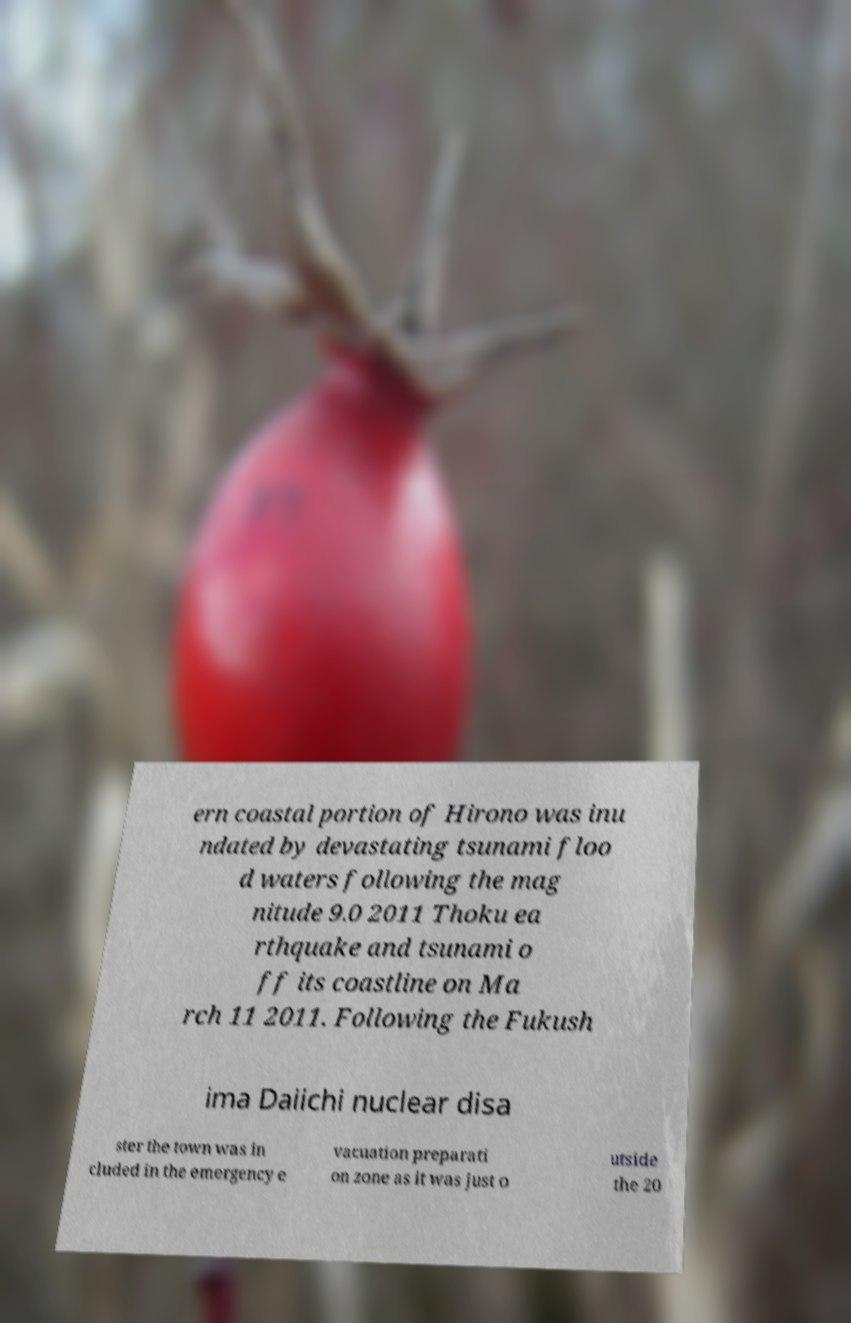Could you extract and type out the text from this image? ern coastal portion of Hirono was inu ndated by devastating tsunami floo d waters following the mag nitude 9.0 2011 Thoku ea rthquake and tsunami o ff its coastline on Ma rch 11 2011. Following the Fukush ima Daiichi nuclear disa ster the town was in cluded in the emergency e vacuation preparati on zone as it was just o utside the 20 